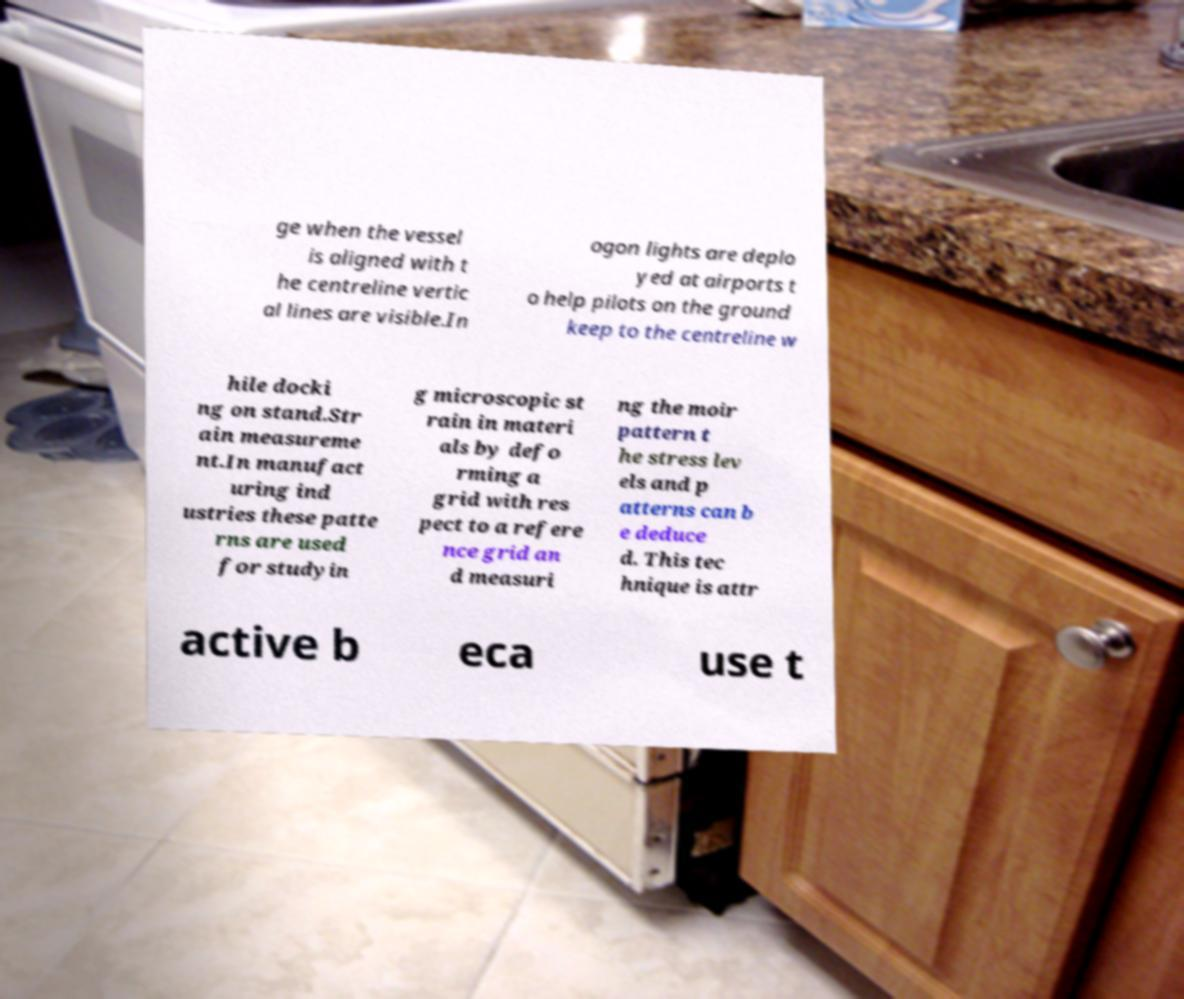Could you assist in decoding the text presented in this image and type it out clearly? ge when the vessel is aligned with t he centreline vertic al lines are visible.In ogon lights are deplo yed at airports t o help pilots on the ground keep to the centreline w hile docki ng on stand.Str ain measureme nt.In manufact uring ind ustries these patte rns are used for studyin g microscopic st rain in materi als by defo rming a grid with res pect to a refere nce grid an d measuri ng the moir pattern t he stress lev els and p atterns can b e deduce d. This tec hnique is attr active b eca use t 